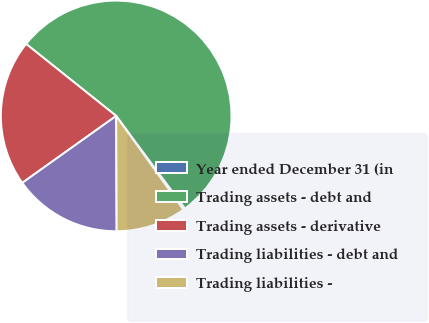Convert chart. <chart><loc_0><loc_0><loc_500><loc_500><pie_chart><fcel>Year ended December 31 (in<fcel>Trading assets - debt and<fcel>Trading assets - derivative<fcel>Trading liabilities - debt and<fcel>Trading liabilities -<nl><fcel>0.28%<fcel>54.1%<fcel>20.59%<fcel>15.21%<fcel>9.83%<nl></chart> 